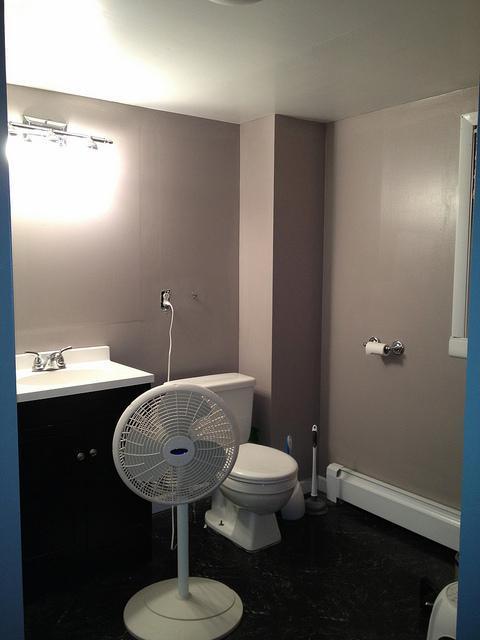How many lights are there?
Give a very brief answer. 1. How many windows are in the picture?
Give a very brief answer. 0. 